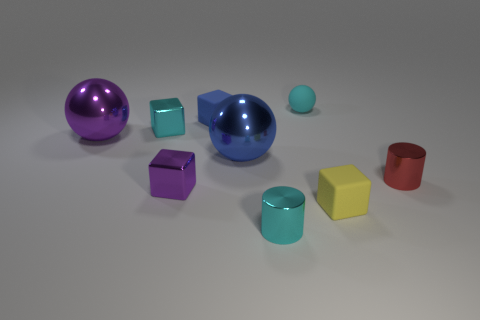How many objects are either tiny cylinders to the right of the tiny yellow matte cube or tiny blocks behind the red metal object?
Make the answer very short. 3. There is a small purple object that is the same material as the tiny red cylinder; what is its shape?
Give a very brief answer. Cube. Is there anything else that is the same color as the tiny sphere?
Give a very brief answer. Yes. There is a purple thing that is the same shape as the tiny cyan matte thing; what is it made of?
Offer a terse response. Metal. What number of other objects are the same size as the cyan rubber thing?
Ensure brevity in your answer.  6. What material is the tiny yellow object?
Give a very brief answer. Rubber. Are there more cyan cubes that are on the right side of the large blue sphere than tiny red cylinders?
Offer a very short reply. No. Are any green rubber spheres visible?
Your answer should be very brief. No. What number of other objects are there of the same shape as the yellow thing?
Keep it short and to the point. 3. There is a big thing that is to the right of the tiny cyan cube; is its color the same as the tiny metallic thing behind the big blue sphere?
Offer a terse response. No. 